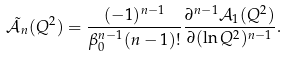<formula> <loc_0><loc_0><loc_500><loc_500>\tilde { { \mathcal { A } } _ { n } } ( Q ^ { 2 } ) = \frac { ( - 1 ) ^ { n - 1 } } { \beta _ { 0 } ^ { n - 1 } ( n - 1 ) ! } \frac { \partial ^ { n - 1 } { \mathcal { A } } _ { 1 } ( Q ^ { 2 } ) } { \partial ( \ln Q ^ { 2 } ) ^ { n - 1 } } .</formula> 